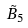Convert formula to latex. <formula><loc_0><loc_0><loc_500><loc_500>\tilde { B } _ { 5 }</formula> 